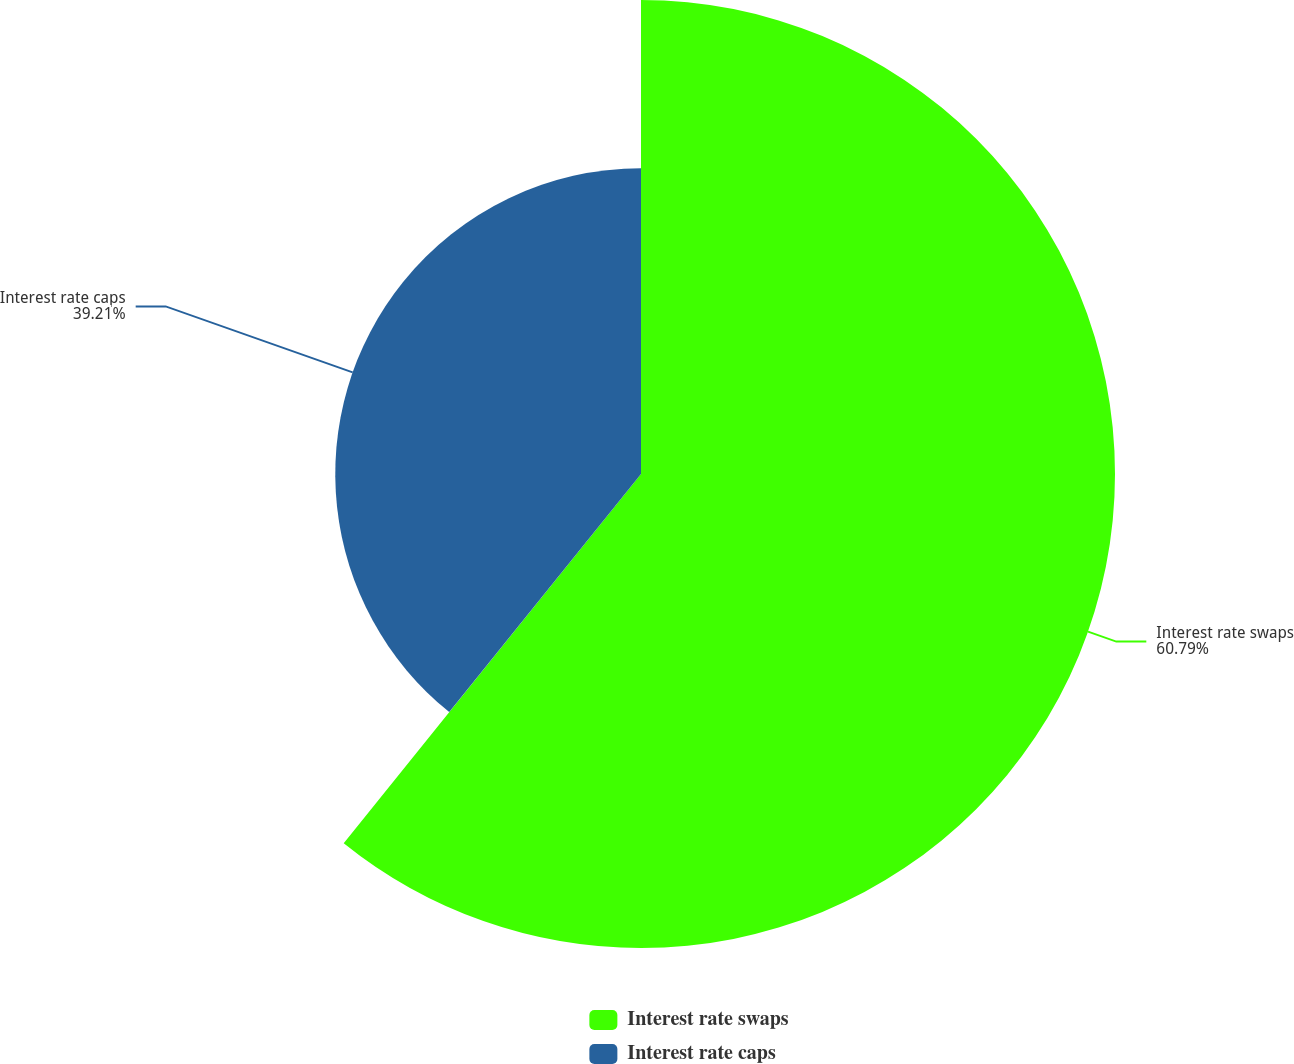<chart> <loc_0><loc_0><loc_500><loc_500><pie_chart><fcel>Interest rate swaps<fcel>Interest rate caps<nl><fcel>60.79%<fcel>39.21%<nl></chart> 